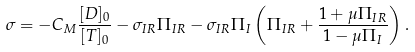Convert formula to latex. <formula><loc_0><loc_0><loc_500><loc_500>\sigma = - C _ { M } \frac { [ D ] _ { 0 } } { [ T ] _ { 0 } } - \sigma _ { I R } \Pi _ { I R } - \sigma _ { I R } \Pi _ { I } \left ( \Pi _ { I R } + \frac { 1 + \mu \Pi _ { I R } } { 1 - \mu \Pi _ { I } } \right ) .</formula> 